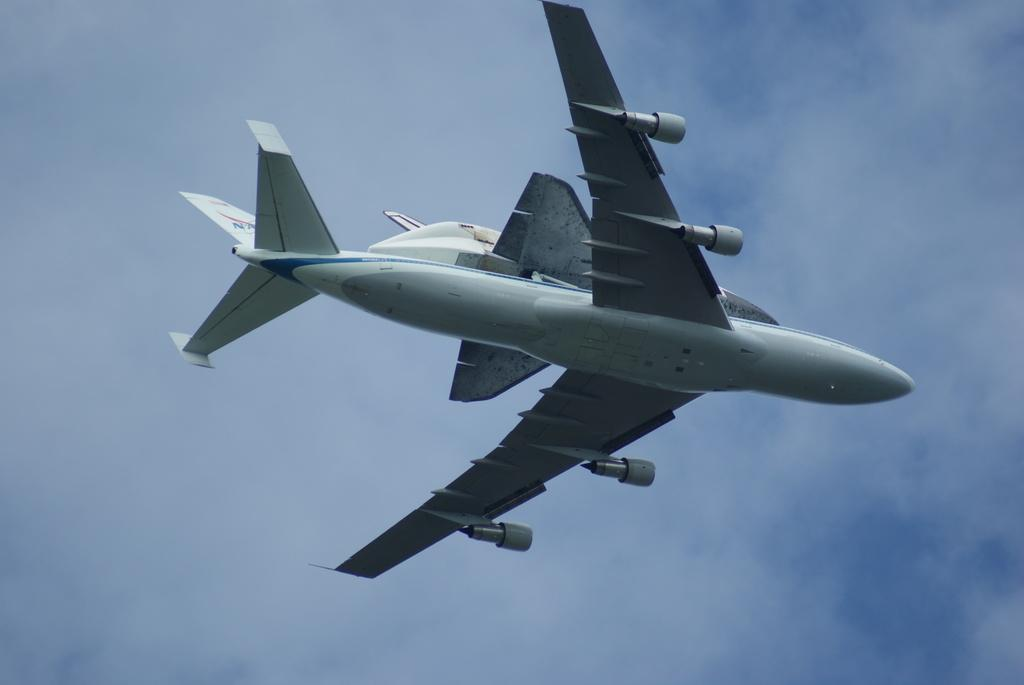What is the main subject of the image? The main subject of the image is an airplane flying in the air. What can be seen in the background of the image? There are clouds in the sky in the background of the image. What type of arm is visible in the image? There is no arm present in the image; it features an airplane flying in the air and clouds in the sky. What arithmetic problem can be solved using the clouds in the image? The clouds in the image are not related to arithmetic problems, so it is not possible to solve any arithmetic problems using the clouds in the image. 